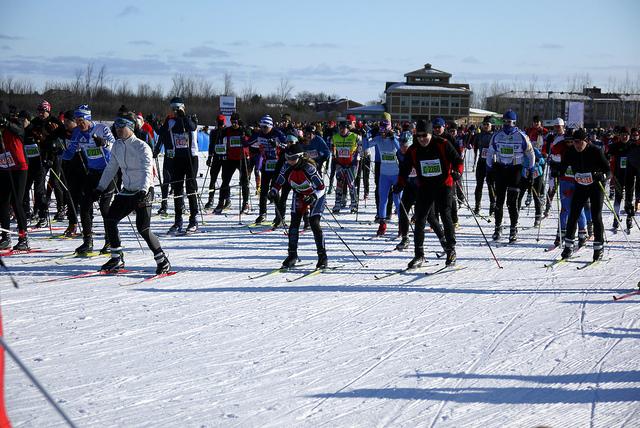What sport are they engaging in?
Keep it brief. Skiing. Is the skier in front wearing traditional ski clothing?
Give a very brief answer. Yes. Is this a race?
Concise answer only. Yes. What number of people are standing in the snow?
Concise answer only. 25. Could the fall like dominoes?
Keep it brief. Yes. 